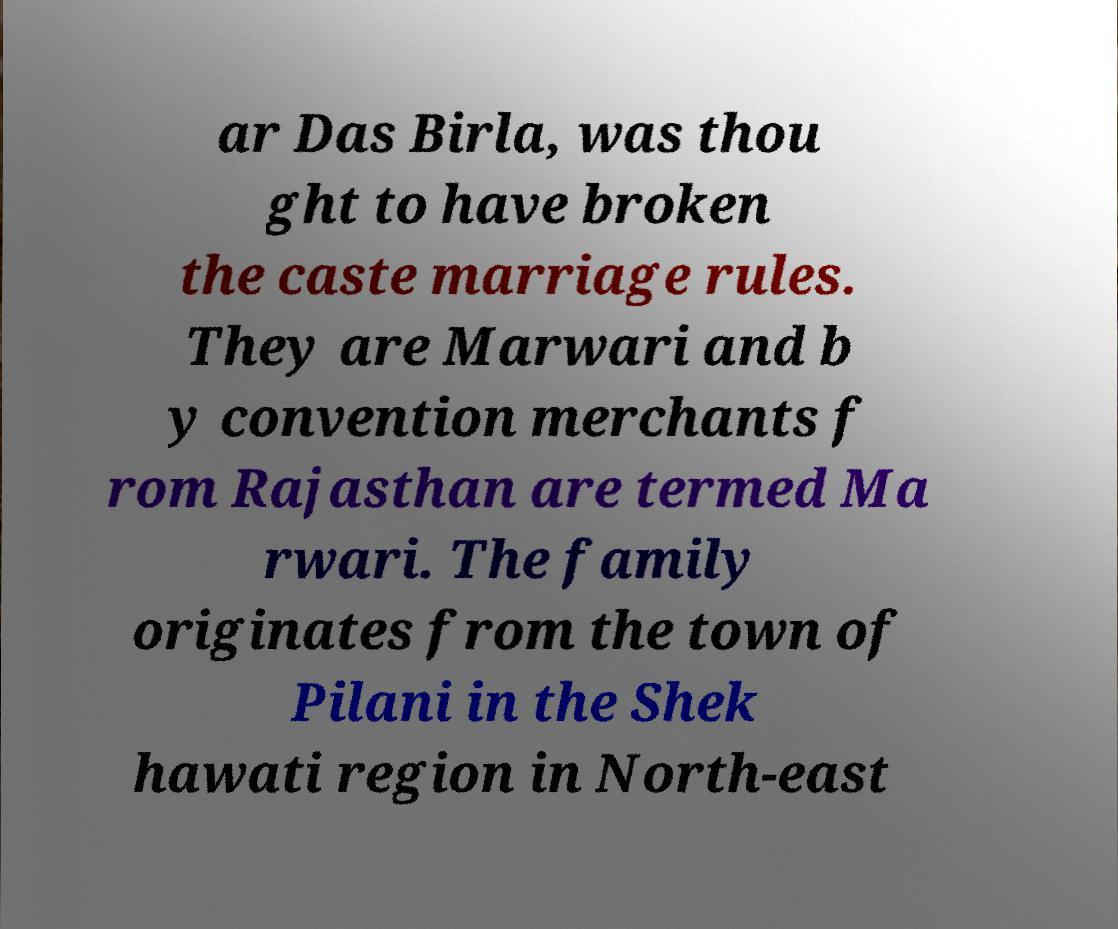For documentation purposes, I need the text within this image transcribed. Could you provide that? ar Das Birla, was thou ght to have broken the caste marriage rules. They are Marwari and b y convention merchants f rom Rajasthan are termed Ma rwari. The family originates from the town of Pilani in the Shek hawati region in North-east 